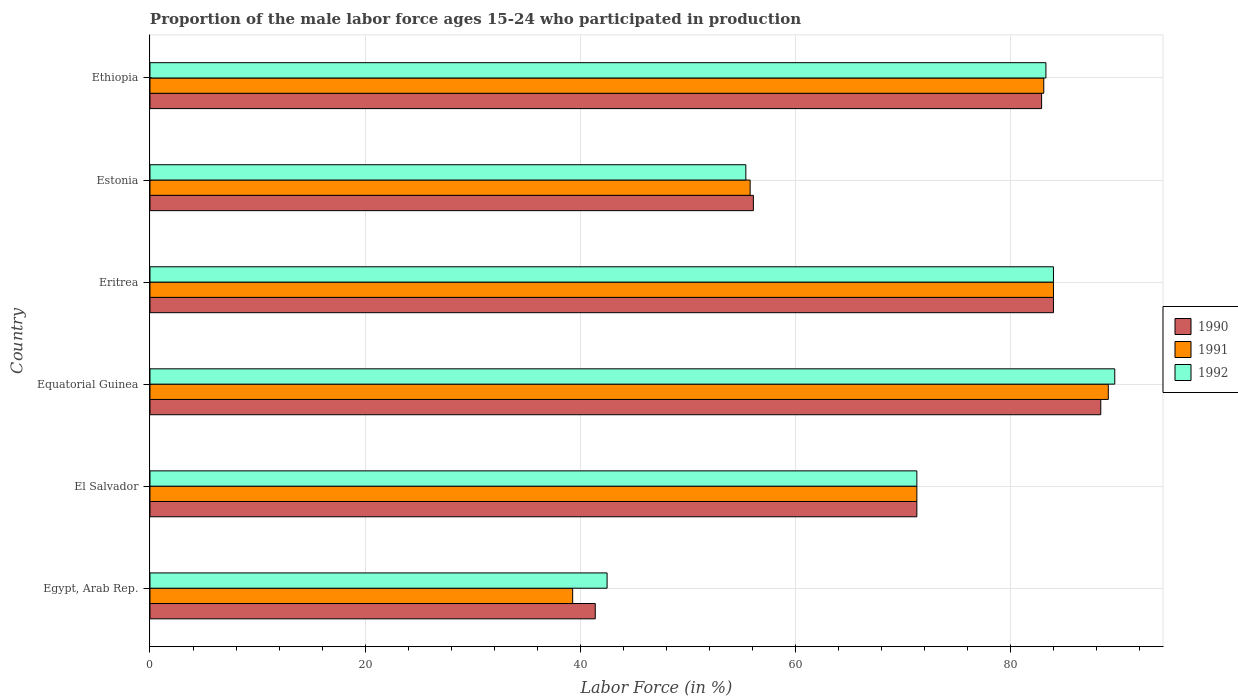How many different coloured bars are there?
Keep it short and to the point. 3. Are the number of bars per tick equal to the number of legend labels?
Your response must be concise. Yes. How many bars are there on the 3rd tick from the top?
Provide a succinct answer. 3. How many bars are there on the 3rd tick from the bottom?
Keep it short and to the point. 3. What is the label of the 4th group of bars from the top?
Keep it short and to the point. Equatorial Guinea. In how many cases, is the number of bars for a given country not equal to the number of legend labels?
Provide a short and direct response. 0. What is the proportion of the male labor force who participated in production in 1990 in Egypt, Arab Rep.?
Your response must be concise. 41.4. Across all countries, what is the maximum proportion of the male labor force who participated in production in 1990?
Ensure brevity in your answer.  88.4. Across all countries, what is the minimum proportion of the male labor force who participated in production in 1990?
Your response must be concise. 41.4. In which country was the proportion of the male labor force who participated in production in 1991 maximum?
Provide a succinct answer. Equatorial Guinea. In which country was the proportion of the male labor force who participated in production in 1990 minimum?
Offer a very short reply. Egypt, Arab Rep. What is the total proportion of the male labor force who participated in production in 1990 in the graph?
Your answer should be compact. 424.1. What is the difference between the proportion of the male labor force who participated in production in 1990 in Equatorial Guinea and that in Eritrea?
Keep it short and to the point. 4.4. What is the difference between the proportion of the male labor force who participated in production in 1992 in El Salvador and the proportion of the male labor force who participated in production in 1990 in Estonia?
Your response must be concise. 15.2. What is the average proportion of the male labor force who participated in production in 1992 per country?
Provide a succinct answer. 71.03. What is the difference between the proportion of the male labor force who participated in production in 1991 and proportion of the male labor force who participated in production in 1992 in Egypt, Arab Rep.?
Your answer should be compact. -3.2. In how many countries, is the proportion of the male labor force who participated in production in 1991 greater than 72 %?
Keep it short and to the point. 3. What is the ratio of the proportion of the male labor force who participated in production in 1992 in El Salvador to that in Ethiopia?
Offer a very short reply. 0.86. Is the proportion of the male labor force who participated in production in 1991 in Equatorial Guinea less than that in Eritrea?
Your response must be concise. No. What is the difference between the highest and the second highest proportion of the male labor force who participated in production in 1992?
Ensure brevity in your answer.  5.7. What is the difference between the highest and the lowest proportion of the male labor force who participated in production in 1991?
Your answer should be compact. 49.8. Is the sum of the proportion of the male labor force who participated in production in 1991 in Egypt, Arab Rep. and Equatorial Guinea greater than the maximum proportion of the male labor force who participated in production in 1990 across all countries?
Keep it short and to the point. Yes. Is it the case that in every country, the sum of the proportion of the male labor force who participated in production in 1990 and proportion of the male labor force who participated in production in 1992 is greater than the proportion of the male labor force who participated in production in 1991?
Provide a succinct answer. Yes. How many countries are there in the graph?
Ensure brevity in your answer.  6. Are the values on the major ticks of X-axis written in scientific E-notation?
Ensure brevity in your answer.  No. Does the graph contain grids?
Give a very brief answer. Yes. Where does the legend appear in the graph?
Your response must be concise. Center right. What is the title of the graph?
Your answer should be compact. Proportion of the male labor force ages 15-24 who participated in production. What is the label or title of the X-axis?
Make the answer very short. Labor Force (in %). What is the label or title of the Y-axis?
Your response must be concise. Country. What is the Labor Force (in %) of 1990 in Egypt, Arab Rep.?
Your response must be concise. 41.4. What is the Labor Force (in %) of 1991 in Egypt, Arab Rep.?
Offer a very short reply. 39.3. What is the Labor Force (in %) of 1992 in Egypt, Arab Rep.?
Your answer should be very brief. 42.5. What is the Labor Force (in %) in 1990 in El Salvador?
Provide a succinct answer. 71.3. What is the Labor Force (in %) of 1991 in El Salvador?
Offer a terse response. 71.3. What is the Labor Force (in %) of 1992 in El Salvador?
Make the answer very short. 71.3. What is the Labor Force (in %) of 1990 in Equatorial Guinea?
Your answer should be very brief. 88.4. What is the Labor Force (in %) of 1991 in Equatorial Guinea?
Ensure brevity in your answer.  89.1. What is the Labor Force (in %) of 1992 in Equatorial Guinea?
Offer a very short reply. 89.7. What is the Labor Force (in %) in 1992 in Eritrea?
Give a very brief answer. 84. What is the Labor Force (in %) in 1990 in Estonia?
Ensure brevity in your answer.  56.1. What is the Labor Force (in %) of 1991 in Estonia?
Your answer should be very brief. 55.8. What is the Labor Force (in %) of 1992 in Estonia?
Keep it short and to the point. 55.4. What is the Labor Force (in %) of 1990 in Ethiopia?
Provide a succinct answer. 82.9. What is the Labor Force (in %) of 1991 in Ethiopia?
Your response must be concise. 83.1. What is the Labor Force (in %) of 1992 in Ethiopia?
Your answer should be very brief. 83.3. Across all countries, what is the maximum Labor Force (in %) in 1990?
Your answer should be very brief. 88.4. Across all countries, what is the maximum Labor Force (in %) in 1991?
Provide a succinct answer. 89.1. Across all countries, what is the maximum Labor Force (in %) of 1992?
Give a very brief answer. 89.7. Across all countries, what is the minimum Labor Force (in %) of 1990?
Provide a succinct answer. 41.4. Across all countries, what is the minimum Labor Force (in %) of 1991?
Provide a short and direct response. 39.3. Across all countries, what is the minimum Labor Force (in %) of 1992?
Make the answer very short. 42.5. What is the total Labor Force (in %) of 1990 in the graph?
Your answer should be compact. 424.1. What is the total Labor Force (in %) of 1991 in the graph?
Keep it short and to the point. 422.6. What is the total Labor Force (in %) in 1992 in the graph?
Your answer should be compact. 426.2. What is the difference between the Labor Force (in %) in 1990 in Egypt, Arab Rep. and that in El Salvador?
Provide a short and direct response. -29.9. What is the difference between the Labor Force (in %) of 1991 in Egypt, Arab Rep. and that in El Salvador?
Your answer should be very brief. -32. What is the difference between the Labor Force (in %) in 1992 in Egypt, Arab Rep. and that in El Salvador?
Provide a short and direct response. -28.8. What is the difference between the Labor Force (in %) of 1990 in Egypt, Arab Rep. and that in Equatorial Guinea?
Your answer should be compact. -47. What is the difference between the Labor Force (in %) in 1991 in Egypt, Arab Rep. and that in Equatorial Guinea?
Offer a very short reply. -49.8. What is the difference between the Labor Force (in %) in 1992 in Egypt, Arab Rep. and that in Equatorial Guinea?
Provide a succinct answer. -47.2. What is the difference between the Labor Force (in %) in 1990 in Egypt, Arab Rep. and that in Eritrea?
Ensure brevity in your answer.  -42.6. What is the difference between the Labor Force (in %) of 1991 in Egypt, Arab Rep. and that in Eritrea?
Make the answer very short. -44.7. What is the difference between the Labor Force (in %) of 1992 in Egypt, Arab Rep. and that in Eritrea?
Provide a succinct answer. -41.5. What is the difference between the Labor Force (in %) in 1990 in Egypt, Arab Rep. and that in Estonia?
Offer a very short reply. -14.7. What is the difference between the Labor Force (in %) in 1991 in Egypt, Arab Rep. and that in Estonia?
Ensure brevity in your answer.  -16.5. What is the difference between the Labor Force (in %) in 1990 in Egypt, Arab Rep. and that in Ethiopia?
Provide a succinct answer. -41.5. What is the difference between the Labor Force (in %) of 1991 in Egypt, Arab Rep. and that in Ethiopia?
Your answer should be very brief. -43.8. What is the difference between the Labor Force (in %) in 1992 in Egypt, Arab Rep. and that in Ethiopia?
Provide a succinct answer. -40.8. What is the difference between the Labor Force (in %) of 1990 in El Salvador and that in Equatorial Guinea?
Give a very brief answer. -17.1. What is the difference between the Labor Force (in %) in 1991 in El Salvador and that in Equatorial Guinea?
Keep it short and to the point. -17.8. What is the difference between the Labor Force (in %) of 1992 in El Salvador and that in Equatorial Guinea?
Ensure brevity in your answer.  -18.4. What is the difference between the Labor Force (in %) in 1991 in El Salvador and that in Eritrea?
Offer a very short reply. -12.7. What is the difference between the Labor Force (in %) in 1991 in El Salvador and that in Estonia?
Provide a succinct answer. 15.5. What is the difference between the Labor Force (in %) of 1990 in El Salvador and that in Ethiopia?
Offer a terse response. -11.6. What is the difference between the Labor Force (in %) of 1992 in El Salvador and that in Ethiopia?
Make the answer very short. -12. What is the difference between the Labor Force (in %) in 1992 in Equatorial Guinea and that in Eritrea?
Your answer should be very brief. 5.7. What is the difference between the Labor Force (in %) in 1990 in Equatorial Guinea and that in Estonia?
Your answer should be very brief. 32.3. What is the difference between the Labor Force (in %) in 1991 in Equatorial Guinea and that in Estonia?
Offer a very short reply. 33.3. What is the difference between the Labor Force (in %) of 1992 in Equatorial Guinea and that in Estonia?
Your answer should be very brief. 34.3. What is the difference between the Labor Force (in %) of 1990 in Eritrea and that in Estonia?
Your answer should be compact. 27.9. What is the difference between the Labor Force (in %) in 1991 in Eritrea and that in Estonia?
Give a very brief answer. 28.2. What is the difference between the Labor Force (in %) of 1992 in Eritrea and that in Estonia?
Offer a terse response. 28.6. What is the difference between the Labor Force (in %) in 1991 in Eritrea and that in Ethiopia?
Your response must be concise. 0.9. What is the difference between the Labor Force (in %) in 1990 in Estonia and that in Ethiopia?
Your response must be concise. -26.8. What is the difference between the Labor Force (in %) in 1991 in Estonia and that in Ethiopia?
Ensure brevity in your answer.  -27.3. What is the difference between the Labor Force (in %) in 1992 in Estonia and that in Ethiopia?
Offer a very short reply. -27.9. What is the difference between the Labor Force (in %) in 1990 in Egypt, Arab Rep. and the Labor Force (in %) in 1991 in El Salvador?
Ensure brevity in your answer.  -29.9. What is the difference between the Labor Force (in %) of 1990 in Egypt, Arab Rep. and the Labor Force (in %) of 1992 in El Salvador?
Make the answer very short. -29.9. What is the difference between the Labor Force (in %) in 1991 in Egypt, Arab Rep. and the Labor Force (in %) in 1992 in El Salvador?
Ensure brevity in your answer.  -32. What is the difference between the Labor Force (in %) of 1990 in Egypt, Arab Rep. and the Labor Force (in %) of 1991 in Equatorial Guinea?
Provide a succinct answer. -47.7. What is the difference between the Labor Force (in %) of 1990 in Egypt, Arab Rep. and the Labor Force (in %) of 1992 in Equatorial Guinea?
Make the answer very short. -48.3. What is the difference between the Labor Force (in %) in 1991 in Egypt, Arab Rep. and the Labor Force (in %) in 1992 in Equatorial Guinea?
Your response must be concise. -50.4. What is the difference between the Labor Force (in %) of 1990 in Egypt, Arab Rep. and the Labor Force (in %) of 1991 in Eritrea?
Your response must be concise. -42.6. What is the difference between the Labor Force (in %) of 1990 in Egypt, Arab Rep. and the Labor Force (in %) of 1992 in Eritrea?
Your response must be concise. -42.6. What is the difference between the Labor Force (in %) in 1991 in Egypt, Arab Rep. and the Labor Force (in %) in 1992 in Eritrea?
Provide a short and direct response. -44.7. What is the difference between the Labor Force (in %) of 1990 in Egypt, Arab Rep. and the Labor Force (in %) of 1991 in Estonia?
Keep it short and to the point. -14.4. What is the difference between the Labor Force (in %) in 1990 in Egypt, Arab Rep. and the Labor Force (in %) in 1992 in Estonia?
Keep it short and to the point. -14. What is the difference between the Labor Force (in %) of 1991 in Egypt, Arab Rep. and the Labor Force (in %) of 1992 in Estonia?
Your answer should be very brief. -16.1. What is the difference between the Labor Force (in %) of 1990 in Egypt, Arab Rep. and the Labor Force (in %) of 1991 in Ethiopia?
Offer a very short reply. -41.7. What is the difference between the Labor Force (in %) of 1990 in Egypt, Arab Rep. and the Labor Force (in %) of 1992 in Ethiopia?
Provide a short and direct response. -41.9. What is the difference between the Labor Force (in %) in 1991 in Egypt, Arab Rep. and the Labor Force (in %) in 1992 in Ethiopia?
Provide a succinct answer. -44. What is the difference between the Labor Force (in %) of 1990 in El Salvador and the Labor Force (in %) of 1991 in Equatorial Guinea?
Your answer should be very brief. -17.8. What is the difference between the Labor Force (in %) of 1990 in El Salvador and the Labor Force (in %) of 1992 in Equatorial Guinea?
Give a very brief answer. -18.4. What is the difference between the Labor Force (in %) in 1991 in El Salvador and the Labor Force (in %) in 1992 in Equatorial Guinea?
Provide a short and direct response. -18.4. What is the difference between the Labor Force (in %) of 1990 in El Salvador and the Labor Force (in %) of 1992 in Eritrea?
Provide a succinct answer. -12.7. What is the difference between the Labor Force (in %) in 1991 in El Salvador and the Labor Force (in %) in 1992 in Eritrea?
Your answer should be very brief. -12.7. What is the difference between the Labor Force (in %) in 1990 in El Salvador and the Labor Force (in %) in 1991 in Estonia?
Offer a terse response. 15.5. What is the difference between the Labor Force (in %) in 1990 in El Salvador and the Labor Force (in %) in 1992 in Estonia?
Keep it short and to the point. 15.9. What is the difference between the Labor Force (in %) of 1991 in El Salvador and the Labor Force (in %) of 1992 in Estonia?
Provide a short and direct response. 15.9. What is the difference between the Labor Force (in %) in 1990 in El Salvador and the Labor Force (in %) in 1992 in Ethiopia?
Offer a terse response. -12. What is the difference between the Labor Force (in %) in 1991 in El Salvador and the Labor Force (in %) in 1992 in Ethiopia?
Your answer should be very brief. -12. What is the difference between the Labor Force (in %) of 1990 in Equatorial Guinea and the Labor Force (in %) of 1992 in Eritrea?
Your response must be concise. 4.4. What is the difference between the Labor Force (in %) in 1991 in Equatorial Guinea and the Labor Force (in %) in 1992 in Eritrea?
Your response must be concise. 5.1. What is the difference between the Labor Force (in %) of 1990 in Equatorial Guinea and the Labor Force (in %) of 1991 in Estonia?
Provide a short and direct response. 32.6. What is the difference between the Labor Force (in %) of 1990 in Equatorial Guinea and the Labor Force (in %) of 1992 in Estonia?
Provide a succinct answer. 33. What is the difference between the Labor Force (in %) in 1991 in Equatorial Guinea and the Labor Force (in %) in 1992 in Estonia?
Offer a terse response. 33.7. What is the difference between the Labor Force (in %) of 1991 in Equatorial Guinea and the Labor Force (in %) of 1992 in Ethiopia?
Your answer should be very brief. 5.8. What is the difference between the Labor Force (in %) of 1990 in Eritrea and the Labor Force (in %) of 1991 in Estonia?
Ensure brevity in your answer.  28.2. What is the difference between the Labor Force (in %) of 1990 in Eritrea and the Labor Force (in %) of 1992 in Estonia?
Your answer should be compact. 28.6. What is the difference between the Labor Force (in %) of 1991 in Eritrea and the Labor Force (in %) of 1992 in Estonia?
Your answer should be compact. 28.6. What is the difference between the Labor Force (in %) of 1990 in Estonia and the Labor Force (in %) of 1991 in Ethiopia?
Provide a short and direct response. -27. What is the difference between the Labor Force (in %) in 1990 in Estonia and the Labor Force (in %) in 1992 in Ethiopia?
Offer a terse response. -27.2. What is the difference between the Labor Force (in %) of 1991 in Estonia and the Labor Force (in %) of 1992 in Ethiopia?
Keep it short and to the point. -27.5. What is the average Labor Force (in %) in 1990 per country?
Give a very brief answer. 70.68. What is the average Labor Force (in %) in 1991 per country?
Provide a succinct answer. 70.43. What is the average Labor Force (in %) in 1992 per country?
Provide a short and direct response. 71.03. What is the difference between the Labor Force (in %) in 1990 and Labor Force (in %) in 1991 in Egypt, Arab Rep.?
Your answer should be very brief. 2.1. What is the difference between the Labor Force (in %) of 1990 and Labor Force (in %) of 1992 in Egypt, Arab Rep.?
Ensure brevity in your answer.  -1.1. What is the difference between the Labor Force (in %) of 1990 and Labor Force (in %) of 1992 in El Salvador?
Offer a terse response. 0. What is the difference between the Labor Force (in %) of 1991 and Labor Force (in %) of 1992 in Equatorial Guinea?
Provide a short and direct response. -0.6. What is the difference between the Labor Force (in %) of 1990 and Labor Force (in %) of 1991 in Eritrea?
Your answer should be compact. 0. What is the difference between the Labor Force (in %) of 1990 and Labor Force (in %) of 1992 in Eritrea?
Provide a short and direct response. 0. What is the difference between the Labor Force (in %) in 1990 and Labor Force (in %) in 1991 in Estonia?
Your response must be concise. 0.3. What is the difference between the Labor Force (in %) of 1990 and Labor Force (in %) of 1992 in Estonia?
Offer a very short reply. 0.7. What is the difference between the Labor Force (in %) of 1990 and Labor Force (in %) of 1992 in Ethiopia?
Keep it short and to the point. -0.4. What is the ratio of the Labor Force (in %) in 1990 in Egypt, Arab Rep. to that in El Salvador?
Offer a very short reply. 0.58. What is the ratio of the Labor Force (in %) in 1991 in Egypt, Arab Rep. to that in El Salvador?
Offer a terse response. 0.55. What is the ratio of the Labor Force (in %) in 1992 in Egypt, Arab Rep. to that in El Salvador?
Keep it short and to the point. 0.6. What is the ratio of the Labor Force (in %) in 1990 in Egypt, Arab Rep. to that in Equatorial Guinea?
Offer a terse response. 0.47. What is the ratio of the Labor Force (in %) in 1991 in Egypt, Arab Rep. to that in Equatorial Guinea?
Ensure brevity in your answer.  0.44. What is the ratio of the Labor Force (in %) in 1992 in Egypt, Arab Rep. to that in Equatorial Guinea?
Offer a terse response. 0.47. What is the ratio of the Labor Force (in %) of 1990 in Egypt, Arab Rep. to that in Eritrea?
Provide a succinct answer. 0.49. What is the ratio of the Labor Force (in %) of 1991 in Egypt, Arab Rep. to that in Eritrea?
Keep it short and to the point. 0.47. What is the ratio of the Labor Force (in %) in 1992 in Egypt, Arab Rep. to that in Eritrea?
Make the answer very short. 0.51. What is the ratio of the Labor Force (in %) of 1990 in Egypt, Arab Rep. to that in Estonia?
Offer a terse response. 0.74. What is the ratio of the Labor Force (in %) of 1991 in Egypt, Arab Rep. to that in Estonia?
Offer a terse response. 0.7. What is the ratio of the Labor Force (in %) in 1992 in Egypt, Arab Rep. to that in Estonia?
Provide a short and direct response. 0.77. What is the ratio of the Labor Force (in %) in 1990 in Egypt, Arab Rep. to that in Ethiopia?
Make the answer very short. 0.5. What is the ratio of the Labor Force (in %) in 1991 in Egypt, Arab Rep. to that in Ethiopia?
Your response must be concise. 0.47. What is the ratio of the Labor Force (in %) in 1992 in Egypt, Arab Rep. to that in Ethiopia?
Your answer should be very brief. 0.51. What is the ratio of the Labor Force (in %) in 1990 in El Salvador to that in Equatorial Guinea?
Give a very brief answer. 0.81. What is the ratio of the Labor Force (in %) of 1991 in El Salvador to that in Equatorial Guinea?
Provide a succinct answer. 0.8. What is the ratio of the Labor Force (in %) of 1992 in El Salvador to that in Equatorial Guinea?
Your answer should be very brief. 0.79. What is the ratio of the Labor Force (in %) of 1990 in El Salvador to that in Eritrea?
Provide a succinct answer. 0.85. What is the ratio of the Labor Force (in %) in 1991 in El Salvador to that in Eritrea?
Your response must be concise. 0.85. What is the ratio of the Labor Force (in %) in 1992 in El Salvador to that in Eritrea?
Make the answer very short. 0.85. What is the ratio of the Labor Force (in %) in 1990 in El Salvador to that in Estonia?
Offer a very short reply. 1.27. What is the ratio of the Labor Force (in %) in 1991 in El Salvador to that in Estonia?
Ensure brevity in your answer.  1.28. What is the ratio of the Labor Force (in %) in 1992 in El Salvador to that in Estonia?
Provide a short and direct response. 1.29. What is the ratio of the Labor Force (in %) of 1990 in El Salvador to that in Ethiopia?
Ensure brevity in your answer.  0.86. What is the ratio of the Labor Force (in %) in 1991 in El Salvador to that in Ethiopia?
Provide a short and direct response. 0.86. What is the ratio of the Labor Force (in %) in 1992 in El Salvador to that in Ethiopia?
Offer a very short reply. 0.86. What is the ratio of the Labor Force (in %) in 1990 in Equatorial Guinea to that in Eritrea?
Provide a succinct answer. 1.05. What is the ratio of the Labor Force (in %) of 1991 in Equatorial Guinea to that in Eritrea?
Your answer should be very brief. 1.06. What is the ratio of the Labor Force (in %) in 1992 in Equatorial Guinea to that in Eritrea?
Provide a succinct answer. 1.07. What is the ratio of the Labor Force (in %) in 1990 in Equatorial Guinea to that in Estonia?
Provide a succinct answer. 1.58. What is the ratio of the Labor Force (in %) in 1991 in Equatorial Guinea to that in Estonia?
Your answer should be very brief. 1.6. What is the ratio of the Labor Force (in %) of 1992 in Equatorial Guinea to that in Estonia?
Ensure brevity in your answer.  1.62. What is the ratio of the Labor Force (in %) of 1990 in Equatorial Guinea to that in Ethiopia?
Offer a very short reply. 1.07. What is the ratio of the Labor Force (in %) in 1991 in Equatorial Guinea to that in Ethiopia?
Offer a terse response. 1.07. What is the ratio of the Labor Force (in %) in 1992 in Equatorial Guinea to that in Ethiopia?
Offer a very short reply. 1.08. What is the ratio of the Labor Force (in %) of 1990 in Eritrea to that in Estonia?
Keep it short and to the point. 1.5. What is the ratio of the Labor Force (in %) in 1991 in Eritrea to that in Estonia?
Make the answer very short. 1.51. What is the ratio of the Labor Force (in %) of 1992 in Eritrea to that in Estonia?
Keep it short and to the point. 1.52. What is the ratio of the Labor Force (in %) in 1990 in Eritrea to that in Ethiopia?
Keep it short and to the point. 1.01. What is the ratio of the Labor Force (in %) of 1991 in Eritrea to that in Ethiopia?
Offer a very short reply. 1.01. What is the ratio of the Labor Force (in %) of 1992 in Eritrea to that in Ethiopia?
Provide a succinct answer. 1.01. What is the ratio of the Labor Force (in %) in 1990 in Estonia to that in Ethiopia?
Your response must be concise. 0.68. What is the ratio of the Labor Force (in %) of 1991 in Estonia to that in Ethiopia?
Give a very brief answer. 0.67. What is the ratio of the Labor Force (in %) of 1992 in Estonia to that in Ethiopia?
Provide a short and direct response. 0.67. What is the difference between the highest and the lowest Labor Force (in %) of 1990?
Offer a terse response. 47. What is the difference between the highest and the lowest Labor Force (in %) of 1991?
Your answer should be very brief. 49.8. What is the difference between the highest and the lowest Labor Force (in %) in 1992?
Provide a succinct answer. 47.2. 